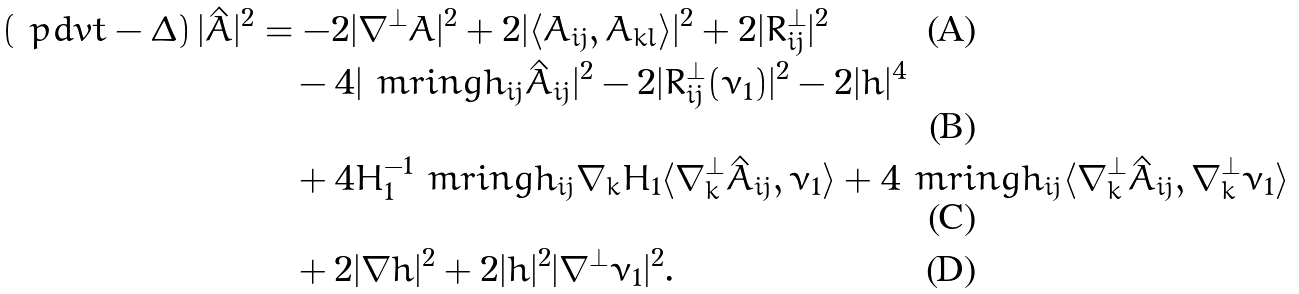<formula> <loc_0><loc_0><loc_500><loc_500>\left ( \ p d v { t } - \Delta \right ) | \hat { A } | ^ { 2 } & = - 2 | \nabla ^ { \perp } A | ^ { 2 } + 2 | \langle A _ { i j } , A _ { k l } \rangle | ^ { 2 } + 2 | R ^ { \perp } _ { i j } | ^ { 2 } \\ & \quad - 4 | \ m r i n g h _ { i j } \hat { A } _ { i j } | ^ { 2 } - 2 | R ^ { \perp } _ { i j } ( \nu _ { 1 } ) | ^ { 2 } - 2 | h | ^ { 4 } \\ & \quad + 4 H _ { 1 } ^ { - 1 } \ m r i n g h _ { i j } \nabla _ { k } H _ { 1 } \langle \nabla _ { k } ^ { \perp } \hat { A } _ { i j } , \nu _ { 1 } \rangle + 4 \ m r i n g h _ { i j } \langle \nabla _ { k } ^ { \perp } \hat { A } _ { i j } , \nabla _ { k } ^ { \perp } \nu _ { 1 } \rangle \\ & \quad + 2 | \nabla h | ^ { 2 } + 2 | h | ^ { 2 } | \nabla ^ { \perp } \nu _ { 1 } | ^ { 2 } .</formula> 